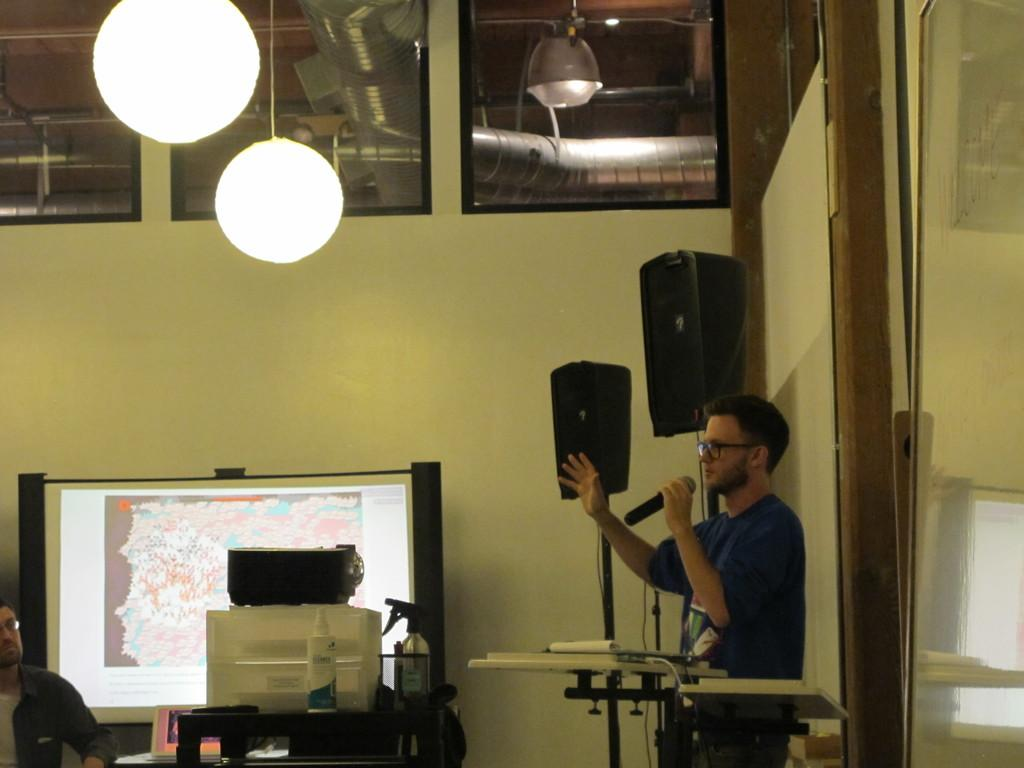What can be seen in the background of the image? There is a wall in the image. What is present in the image that provides illumination? There are lights in the image. What device is used for amplifying sound in the image? There is a sound box in the image. What is the man in the image holding? The man is holding a microphone in the image. What object in the image might contain items or materials? There is a box in the image. What can be used for displaying visual information in the image? There is a screen in the image. How many aunts are present in the image? There are no aunts present in the image. What committee is responsible for organizing the event in the image? There is no committee or event depicted in the image. 